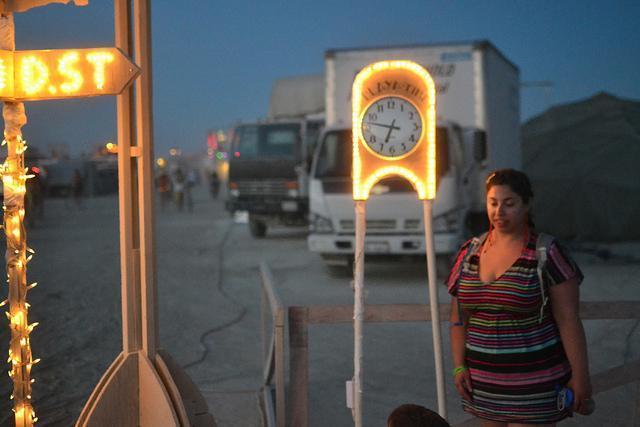How many trucks are there?
Give a very brief answer. 2. How many horses have a rider on them?
Give a very brief answer. 0. 